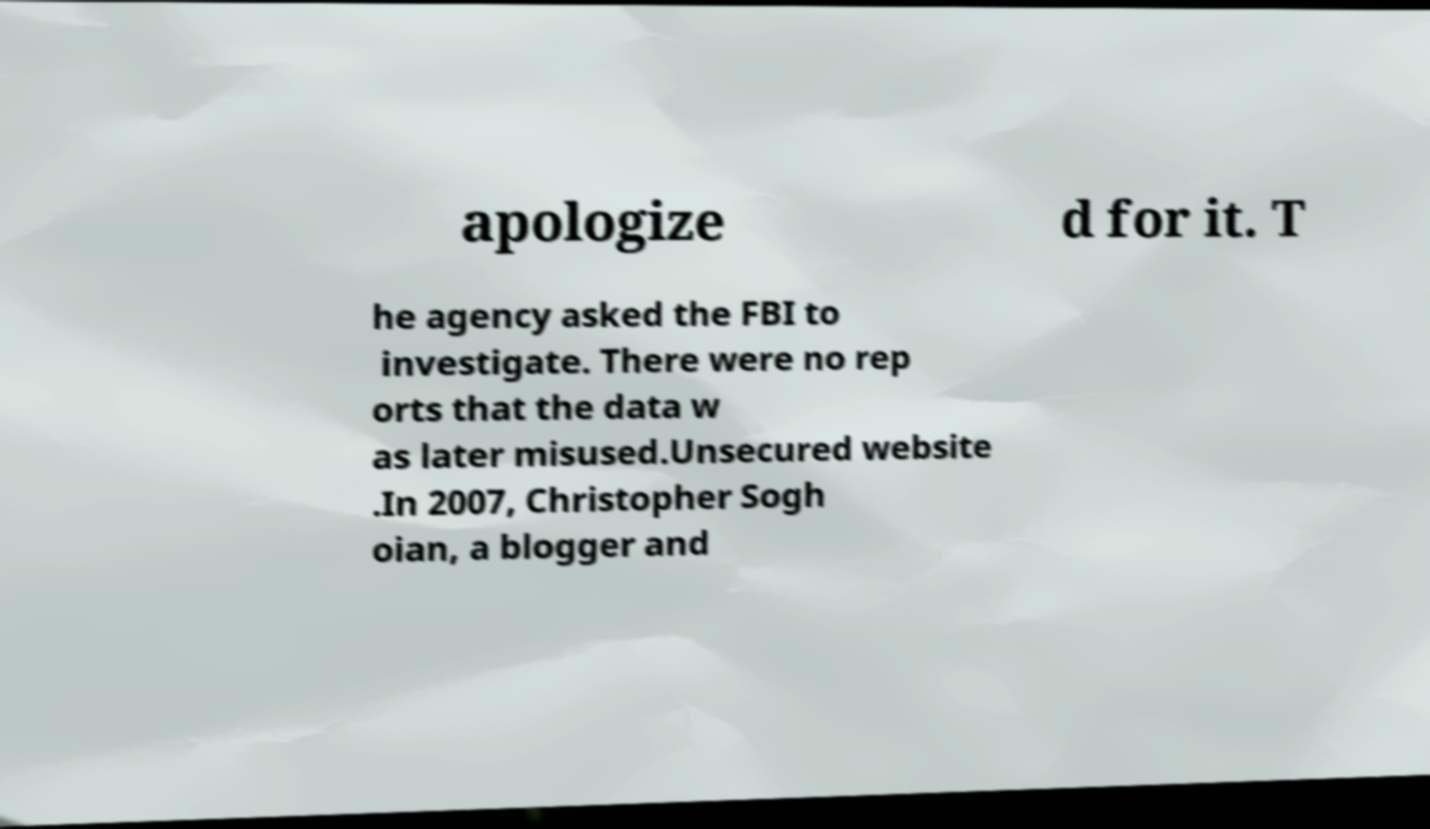Please identify and transcribe the text found in this image. apologize d for it. T he agency asked the FBI to investigate. There were no rep orts that the data w as later misused.Unsecured website .In 2007, Christopher Sogh oian, a blogger and 